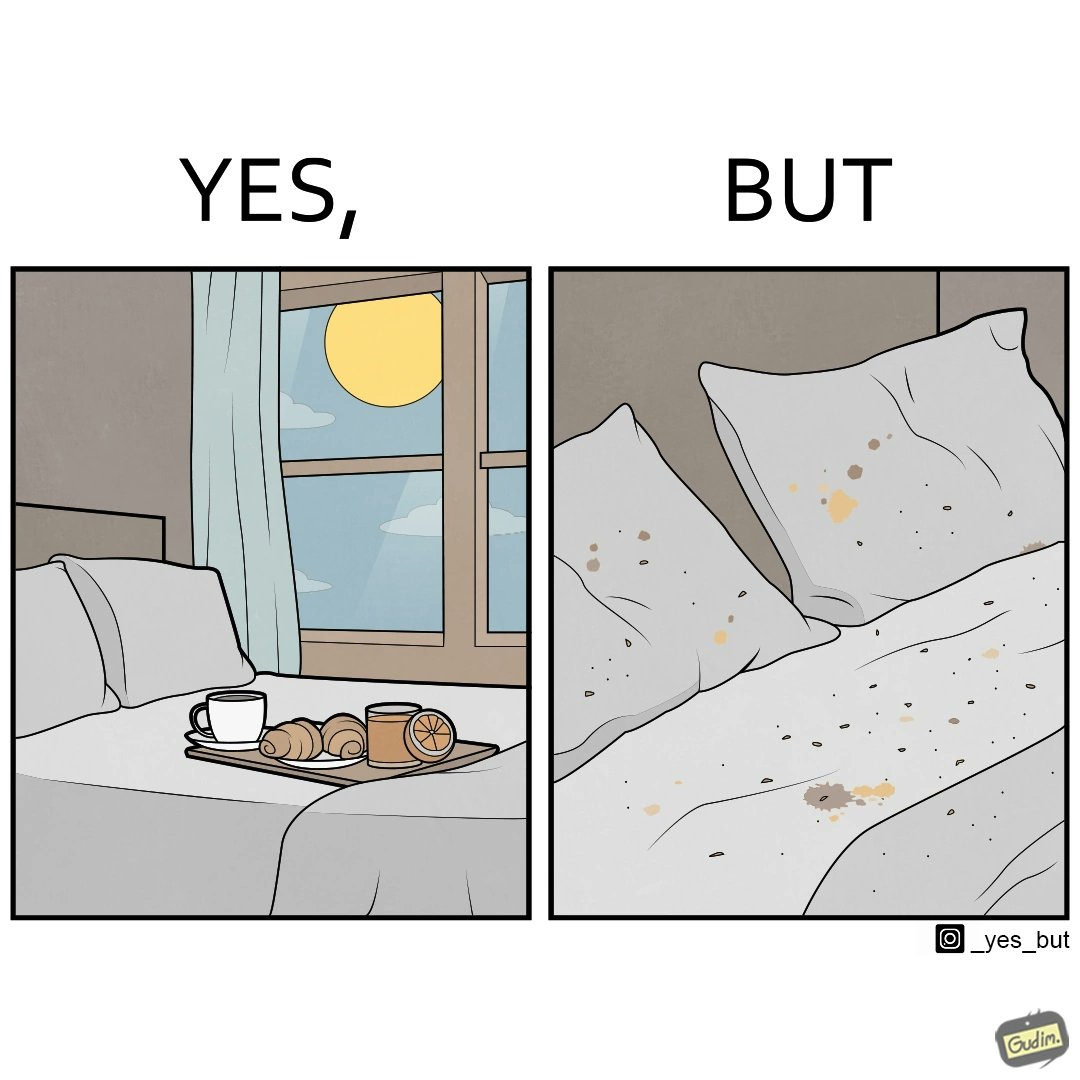Why is this image considered satirical? The image is ironical, as having breakfast in bed is a luxury. However, eating while in bed leads to food crumbs, making the bed dirty, along with the need to clean the bed afterwards. 